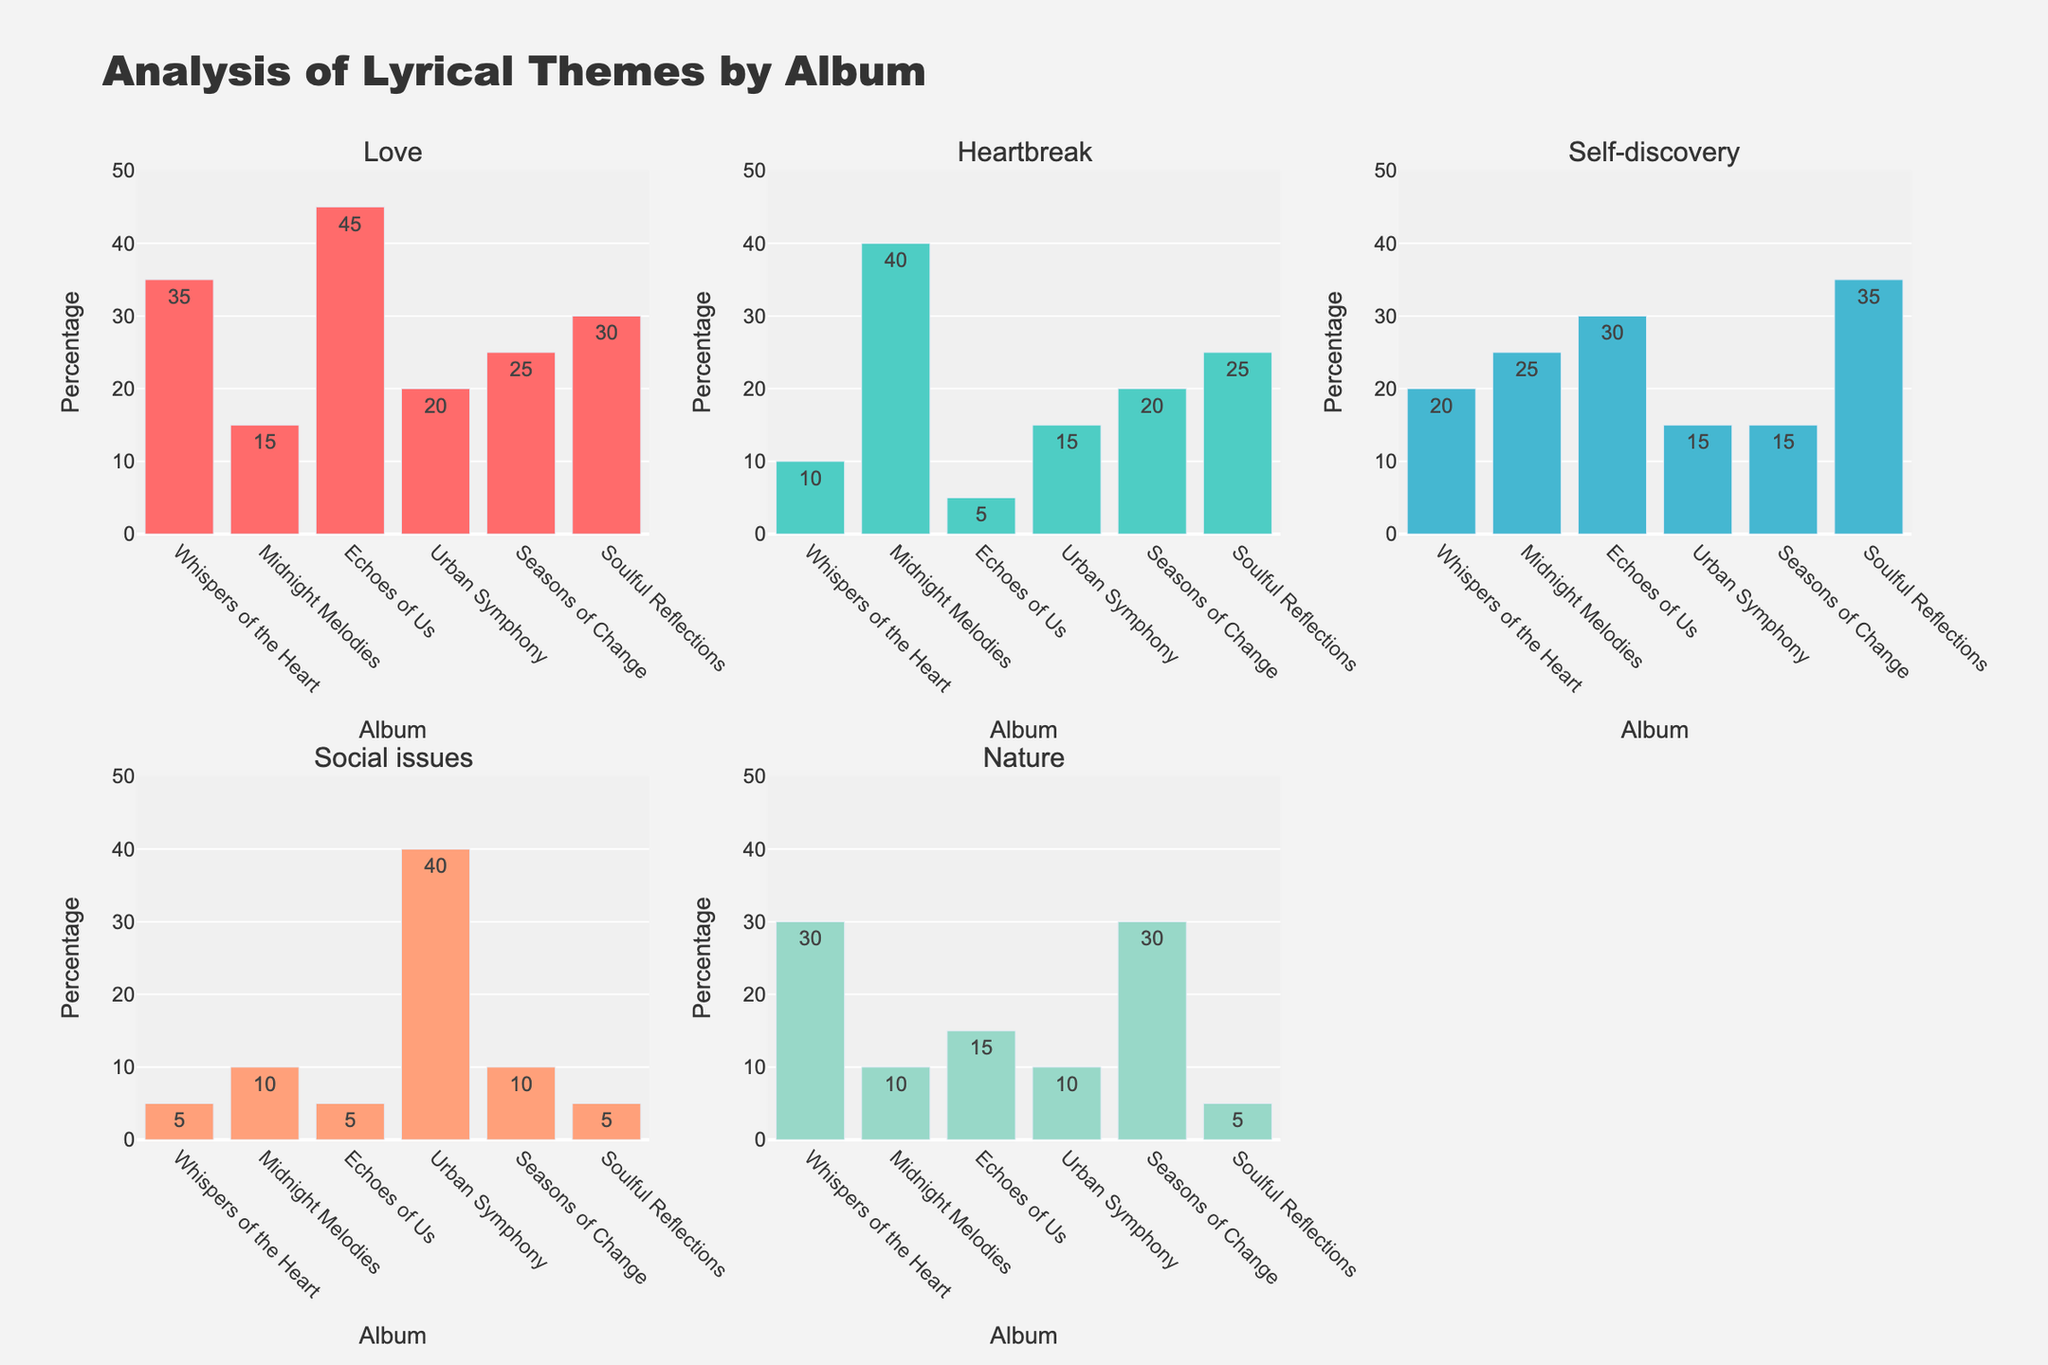Which album has the highest percentage of the 'Love' theme? The subplots show each theme's percentage by album. Check the bar heights in the 'Love' subplot to find which album has the highest value. "Echoes of Us" has the tallest bar, representing 45%.
Answer: "Echoes of Us" Which two albums have the same percentage of the 'Heartbreak' theme? Check the bars in the 'Heartbreak' subplot and identify bars with the same height. "Urban Symphony" and "Seasons of Change" both show a 20% for 'Heartbreak'.
Answer: "Urban Symphony" and "Seasons of Change" What is the combined percentage of 'Social issues' across all albums? Sum all percentages for 'Social issues' found in the 'Social issues' subplot: 5+10+5+40+10+5 = 75%.
Answer: 75% Which theme shows the highest diversity in percentages across albums? Compare the range of values for each theme in their respective subplots. 'Heartbreak' varies from 5% to 40%, while other themes vary less. Thus, 'Heartbreak' shows the highest diversity.
Answer: 'Heartbreak' What's the difference in the percentage of 'Nature' between the albums with the highest and lowest values? Identify the highest and lowest percentages in the 'Nature' subplot. "Whispers of the Heart" has the highest (30%), "Soulful Reflections" has the lowest (5%). Difference: 30%-5%=25%.
Answer: 25% Compare the theme 'Self-discovery' in "Soulful Reflections" and "Midnight Melodies". Which album has a higher percentage and by how much? Check the 'Self-discovery' subplot for both albums. "Soulful Reflections" has 35%, "Midnight Melodies" has 25%. The difference is 35%-25%=10%.
Answer: "Soulful Reflections" by 10% Which album is most thematically balanced based on the lack of extremities in its percentages across themes? Look for an album with relatively similar bar heights across subplots. "Seasons of Change" has more balanced percentages (ranging from 10% to 30%) across all themes compared to others.
Answer: "Seasons of Change" If you were to choose an album with the predominant theme of 'Love' as a tattoo inspiration, which would it be? The subplot for 'Love' shows "Echoes of Us" has the highest percentage in that theme.
Answer: "Echoes of Us" 